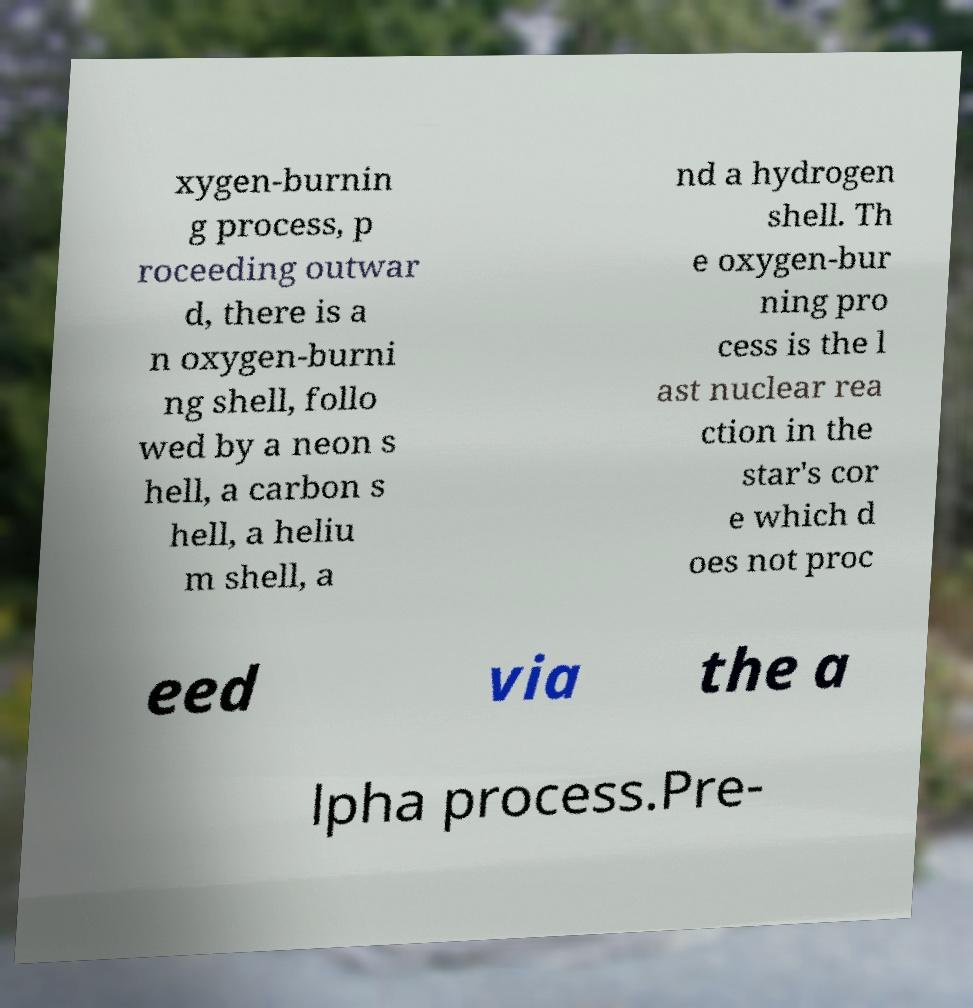What messages or text are displayed in this image? I need them in a readable, typed format. xygen-burnin g process, p roceeding outwar d, there is a n oxygen-burni ng shell, follo wed by a neon s hell, a carbon s hell, a heliu m shell, a nd a hydrogen shell. Th e oxygen-bur ning pro cess is the l ast nuclear rea ction in the star's cor e which d oes not proc eed via the a lpha process.Pre- 